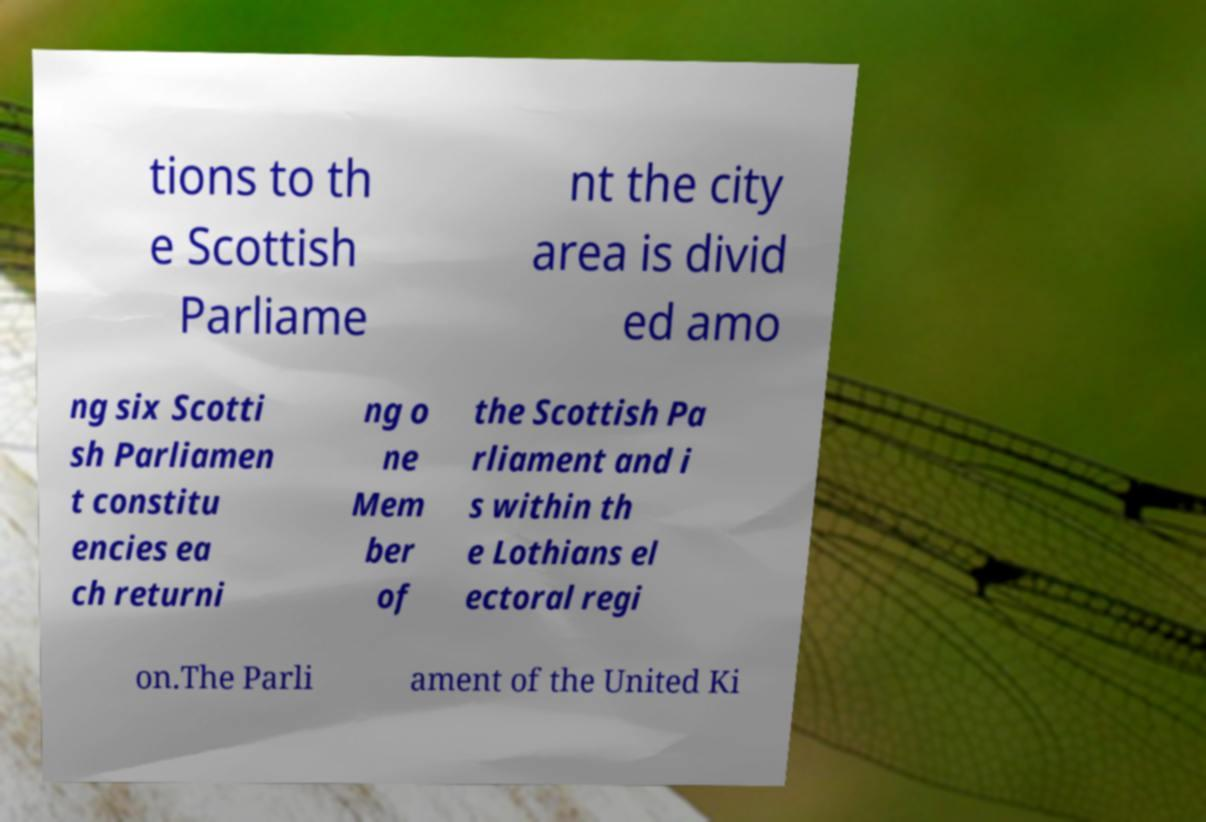Can you read and provide the text displayed in the image?This photo seems to have some interesting text. Can you extract and type it out for me? tions to th e Scottish Parliame nt the city area is divid ed amo ng six Scotti sh Parliamen t constitu encies ea ch returni ng o ne Mem ber of the Scottish Pa rliament and i s within th e Lothians el ectoral regi on.The Parli ament of the United Ki 